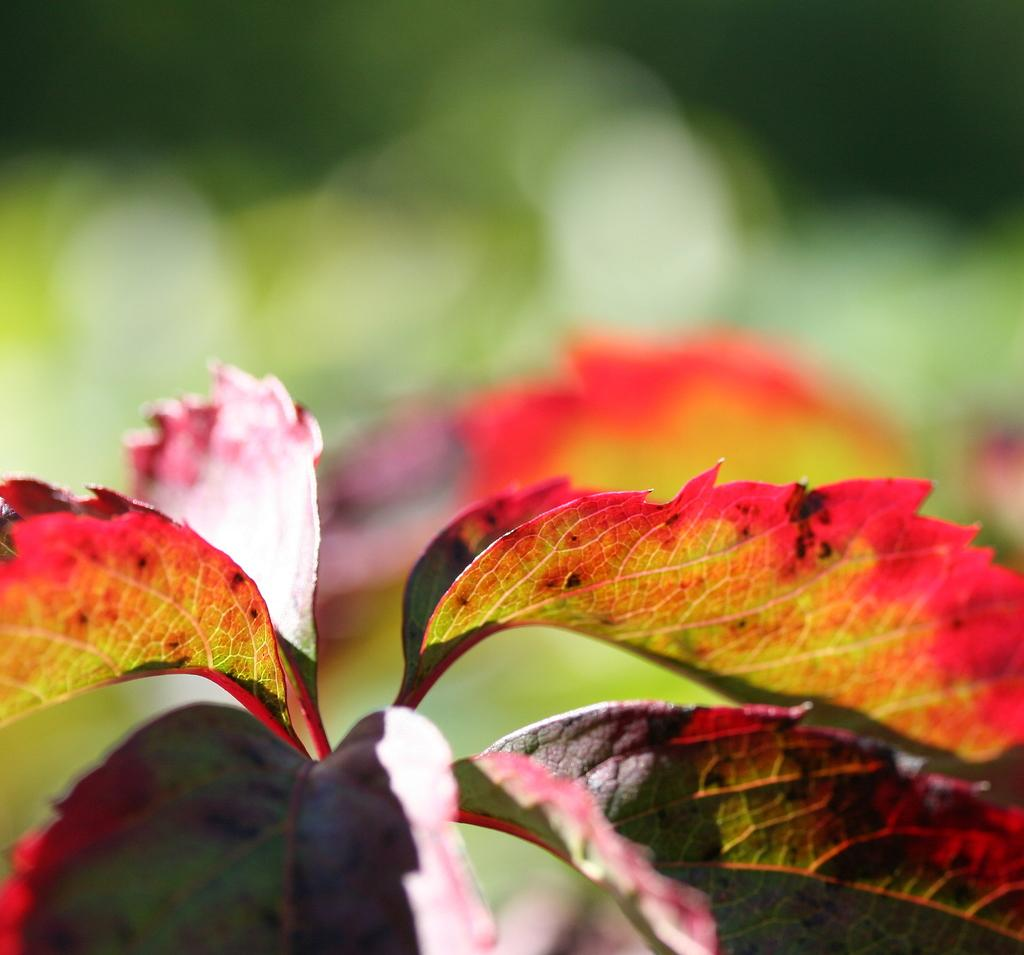What colors are the leaves in the image? The leaves in the image are in pink and green color. Can you describe the background of the image? The background of the image is blurred. Are there any springs visible in the image? There are no springs present in the image; it features leaves in pink and green color with a blurred background. Can you see a cap on any of the leaves in the image? There is no cap present on any of the leaves in the image. 